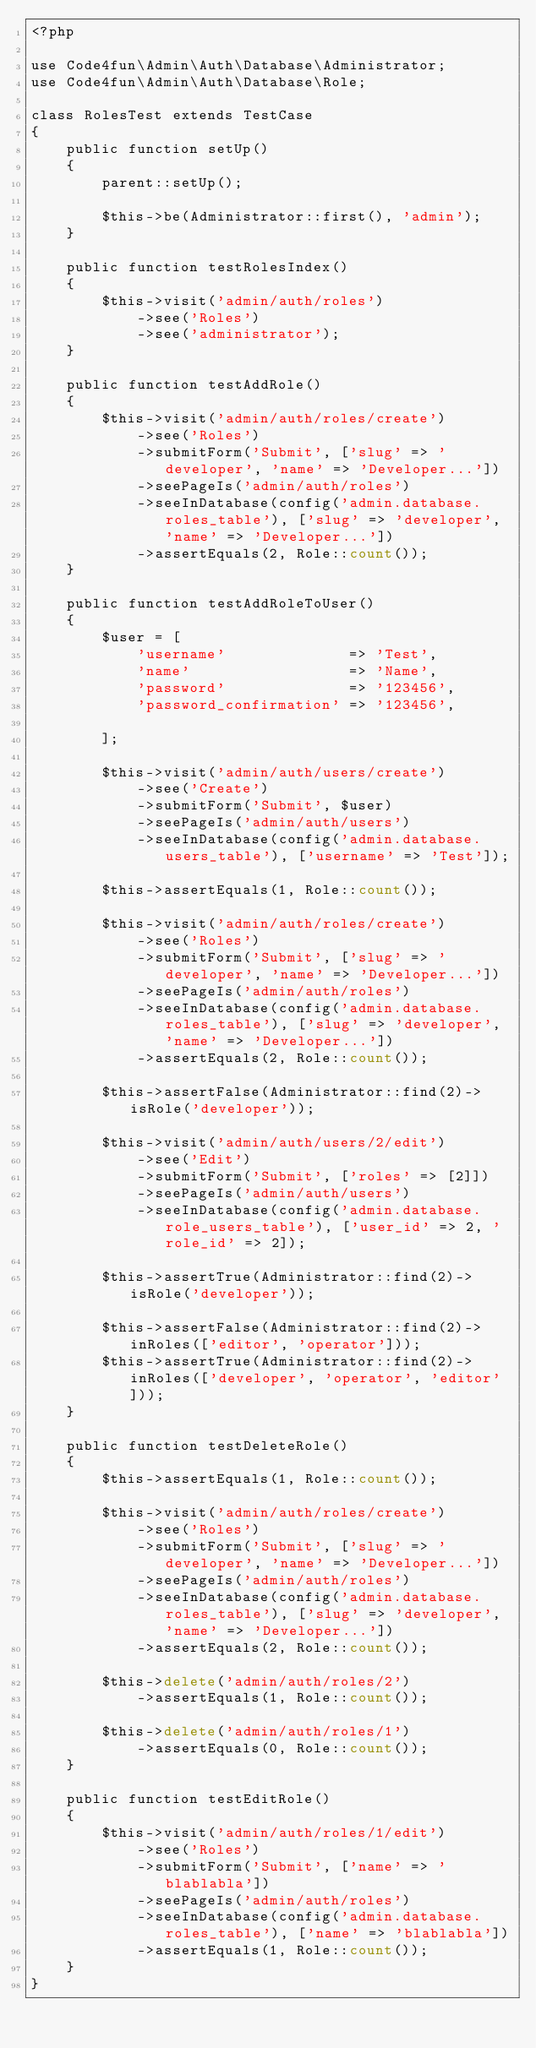<code> <loc_0><loc_0><loc_500><loc_500><_PHP_><?php

use Code4fun\Admin\Auth\Database\Administrator;
use Code4fun\Admin\Auth\Database\Role;

class RolesTest extends TestCase
{
    public function setUp()
    {
        parent::setUp();

        $this->be(Administrator::first(), 'admin');
    }

    public function testRolesIndex()
    {
        $this->visit('admin/auth/roles')
            ->see('Roles')
            ->see('administrator');
    }

    public function testAddRole()
    {
        $this->visit('admin/auth/roles/create')
            ->see('Roles')
            ->submitForm('Submit', ['slug' => 'developer', 'name' => 'Developer...'])
            ->seePageIs('admin/auth/roles')
            ->seeInDatabase(config('admin.database.roles_table'), ['slug' => 'developer', 'name' => 'Developer...'])
            ->assertEquals(2, Role::count());
    }

    public function testAddRoleToUser()
    {
        $user = [
            'username'              => 'Test',
            'name'                  => 'Name',
            'password'              => '123456',
            'password_confirmation' => '123456',

        ];

        $this->visit('admin/auth/users/create')
            ->see('Create')
            ->submitForm('Submit', $user)
            ->seePageIs('admin/auth/users')
            ->seeInDatabase(config('admin.database.users_table'), ['username' => 'Test']);

        $this->assertEquals(1, Role::count());

        $this->visit('admin/auth/roles/create')
            ->see('Roles')
            ->submitForm('Submit', ['slug' => 'developer', 'name' => 'Developer...'])
            ->seePageIs('admin/auth/roles')
            ->seeInDatabase(config('admin.database.roles_table'), ['slug' => 'developer', 'name' => 'Developer...'])
            ->assertEquals(2, Role::count());

        $this->assertFalse(Administrator::find(2)->isRole('developer'));

        $this->visit('admin/auth/users/2/edit')
            ->see('Edit')
            ->submitForm('Submit', ['roles' => [2]])
            ->seePageIs('admin/auth/users')
            ->seeInDatabase(config('admin.database.role_users_table'), ['user_id' => 2, 'role_id' => 2]);

        $this->assertTrue(Administrator::find(2)->isRole('developer'));

        $this->assertFalse(Administrator::find(2)->inRoles(['editor', 'operator']));
        $this->assertTrue(Administrator::find(2)->inRoles(['developer', 'operator', 'editor']));
    }

    public function testDeleteRole()
    {
        $this->assertEquals(1, Role::count());

        $this->visit('admin/auth/roles/create')
            ->see('Roles')
            ->submitForm('Submit', ['slug' => 'developer', 'name' => 'Developer...'])
            ->seePageIs('admin/auth/roles')
            ->seeInDatabase(config('admin.database.roles_table'), ['slug' => 'developer', 'name' => 'Developer...'])
            ->assertEquals(2, Role::count());

        $this->delete('admin/auth/roles/2')
            ->assertEquals(1, Role::count());

        $this->delete('admin/auth/roles/1')
            ->assertEquals(0, Role::count());
    }

    public function testEditRole()
    {
        $this->visit('admin/auth/roles/1/edit')
            ->see('Roles')
            ->submitForm('Submit', ['name' => 'blablabla'])
            ->seePageIs('admin/auth/roles')
            ->seeInDatabase(config('admin.database.roles_table'), ['name' => 'blablabla'])
            ->assertEquals(1, Role::count());
    }
}
</code> 